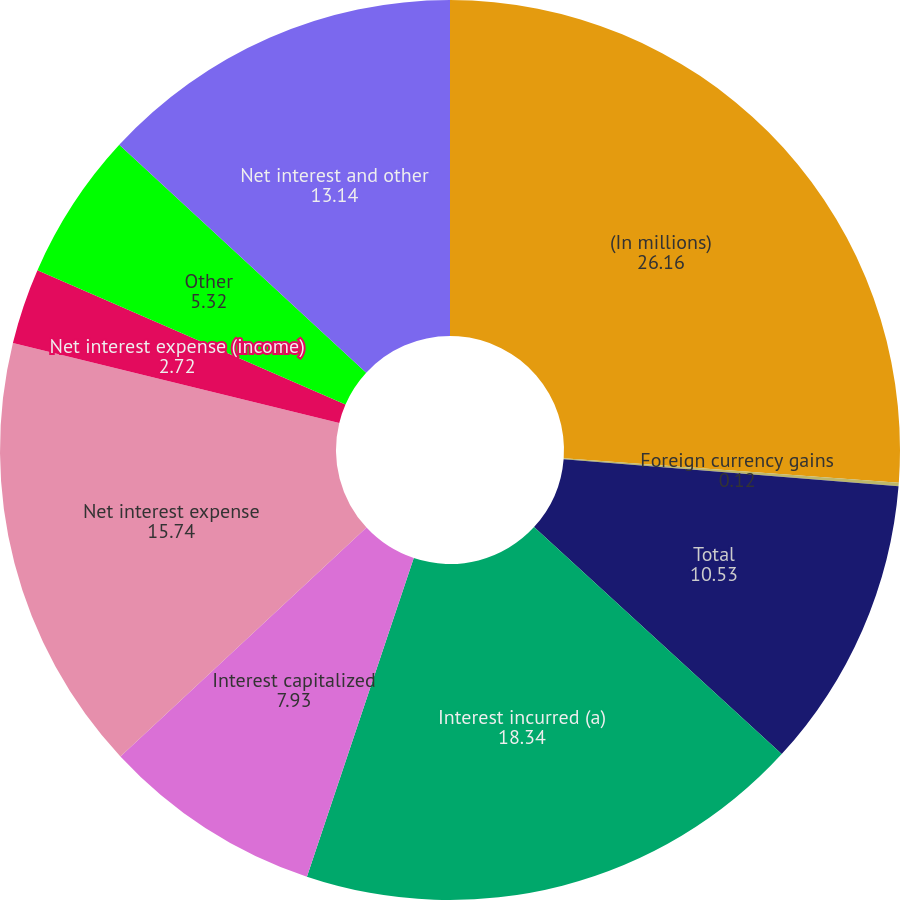<chart> <loc_0><loc_0><loc_500><loc_500><pie_chart><fcel>(In millions)<fcel>Foreign currency gains<fcel>Total<fcel>Interest incurred (a)<fcel>Interest capitalized<fcel>Net interest expense<fcel>Net interest expense (income)<fcel>Other<fcel>Net interest and other<nl><fcel>26.16%<fcel>0.12%<fcel>10.53%<fcel>18.34%<fcel>7.93%<fcel>15.74%<fcel>2.72%<fcel>5.32%<fcel>13.14%<nl></chart> 